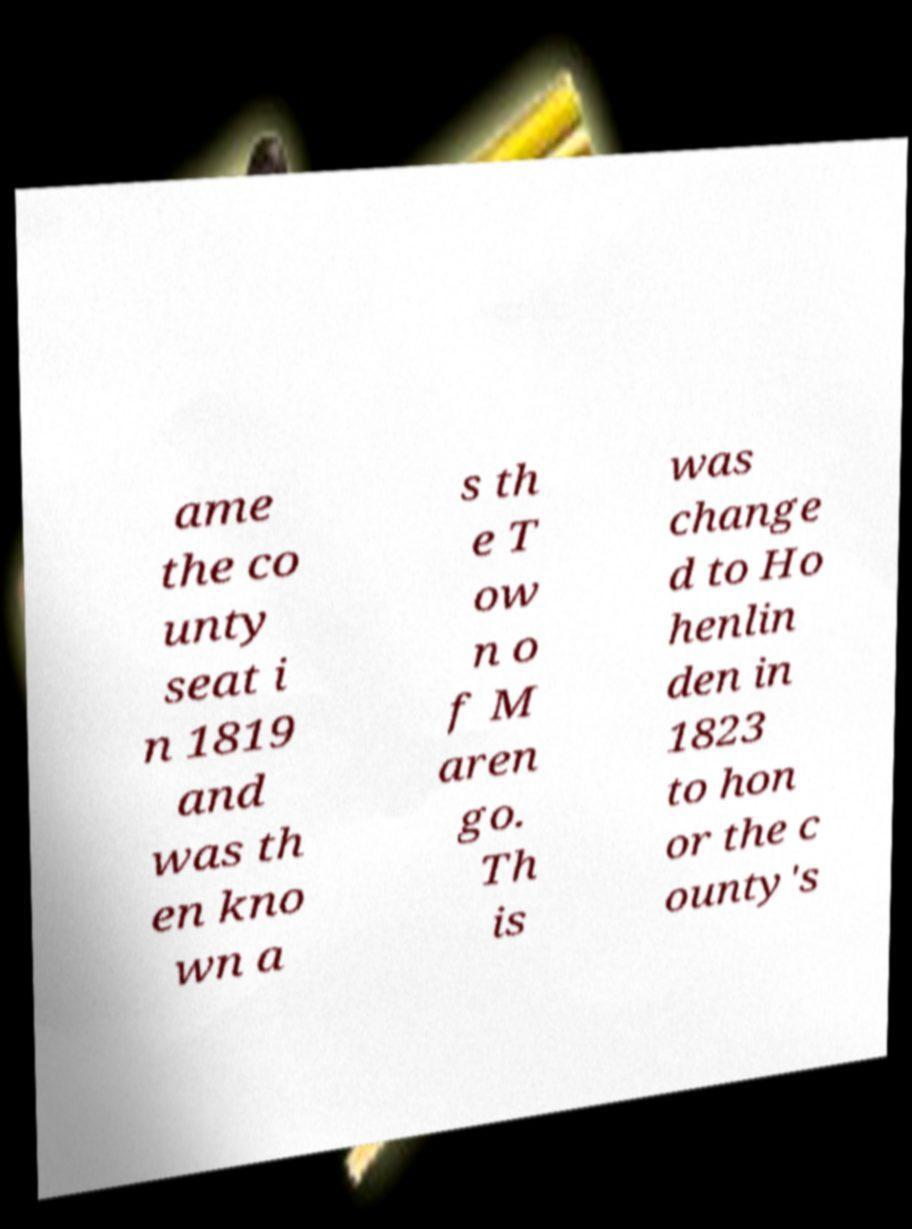Could you extract and type out the text from this image? ame the co unty seat i n 1819 and was th en kno wn a s th e T ow n o f M aren go. Th is was change d to Ho henlin den in 1823 to hon or the c ounty's 